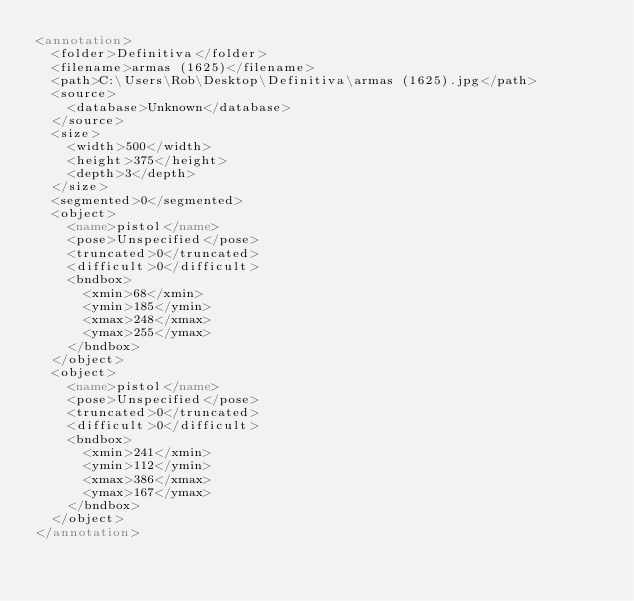<code> <loc_0><loc_0><loc_500><loc_500><_XML_><annotation>
  <folder>Definitiva</folder>
  <filename>armas (1625)</filename>
  <path>C:\Users\Rob\Desktop\Definitiva\armas (1625).jpg</path>
  <source>
    <database>Unknown</database>
  </source>
  <size>
    <width>500</width>
    <height>375</height>
    <depth>3</depth>
  </size>
  <segmented>0</segmented>
  <object>
    <name>pistol</name>
    <pose>Unspecified</pose>
    <truncated>0</truncated>
    <difficult>0</difficult>
    <bndbox>
      <xmin>68</xmin>
      <ymin>185</ymin>
      <xmax>248</xmax>
      <ymax>255</ymax>
    </bndbox>
  </object>
  <object>
    <name>pistol</name>
    <pose>Unspecified</pose>
    <truncated>0</truncated>
    <difficult>0</difficult>
    <bndbox>
      <xmin>241</xmin>
      <ymin>112</ymin>
      <xmax>386</xmax>
      <ymax>167</ymax>
    </bndbox>
  </object>
</annotation>
</code> 